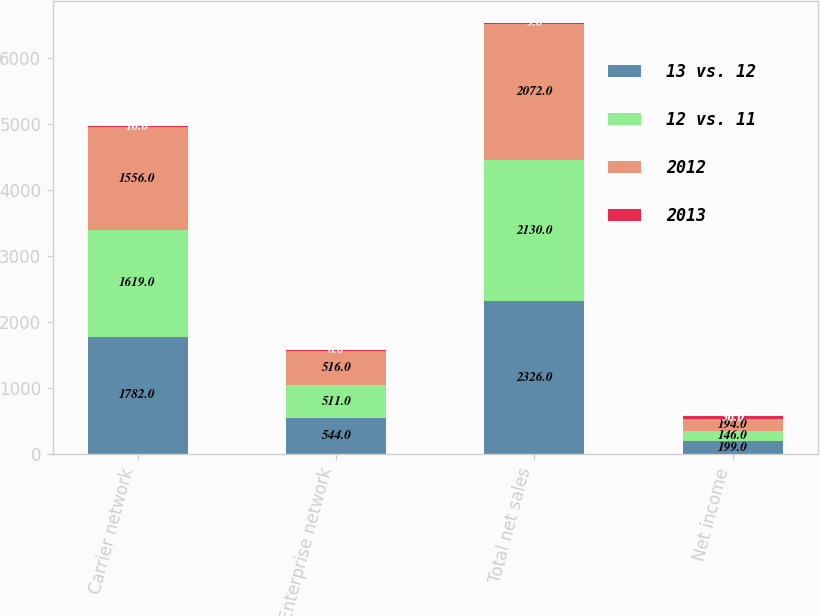Convert chart. <chart><loc_0><loc_0><loc_500><loc_500><stacked_bar_chart><ecel><fcel>Carrier network<fcel>Enterprise network<fcel>Total net sales<fcel>Net income<nl><fcel>13 vs. 12<fcel>1782<fcel>544<fcel>2326<fcel>199<nl><fcel>12 vs. 11<fcel>1619<fcel>511<fcel>2130<fcel>146<nl><fcel>2012<fcel>1556<fcel>516<fcel>2072<fcel>194<nl><fcel>2013<fcel>10<fcel>6<fcel>9<fcel>36<nl></chart> 